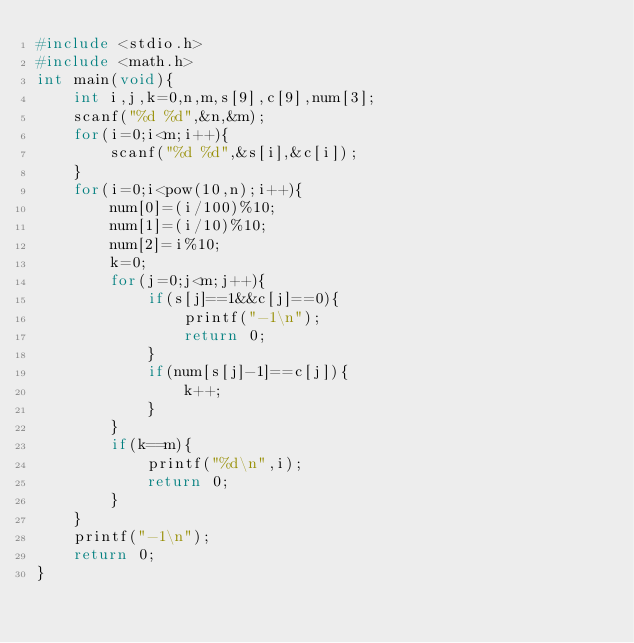Convert code to text. <code><loc_0><loc_0><loc_500><loc_500><_C_>#include <stdio.h>
#include <math.h>
int main(void){
    int i,j,k=0,n,m,s[9],c[9],num[3];
    scanf("%d %d",&n,&m);
    for(i=0;i<m;i++){
        scanf("%d %d",&s[i],&c[i]);
    }
    for(i=0;i<pow(10,n);i++){
        num[0]=(i/100)%10;
        num[1]=(i/10)%10;
        num[2]=i%10;
        k=0;
        for(j=0;j<m;j++){
            if(s[j]==1&&c[j]==0){
                printf("-1\n");
                return 0;
            }
            if(num[s[j]-1]==c[j]){
                k++;
            }
        }
        if(k==m){
            printf("%d\n",i);
            return 0;
        }
    }
    printf("-1\n");
    return 0;
}</code> 